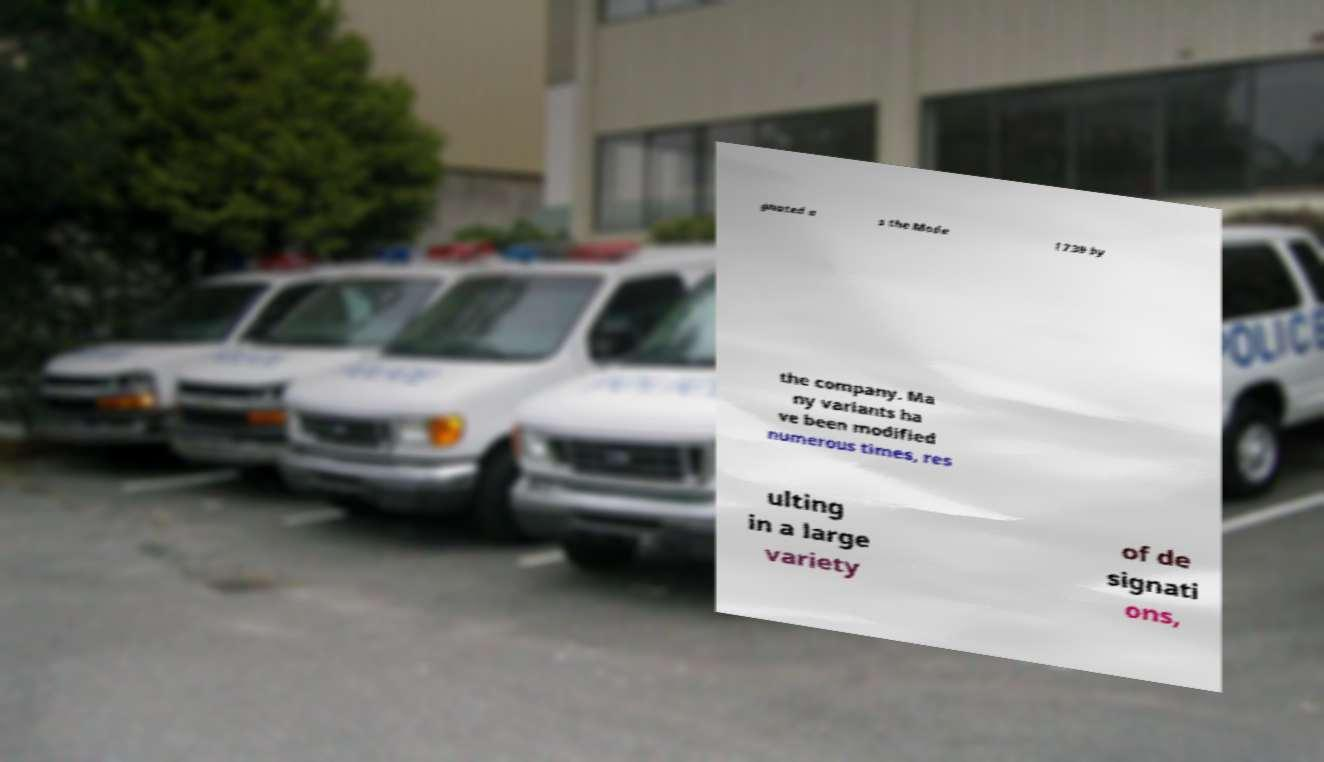Can you accurately transcribe the text from the provided image for me? gnated a s the Mode l 739 by the company. Ma ny variants ha ve been modified numerous times, res ulting in a large variety of de signati ons, 